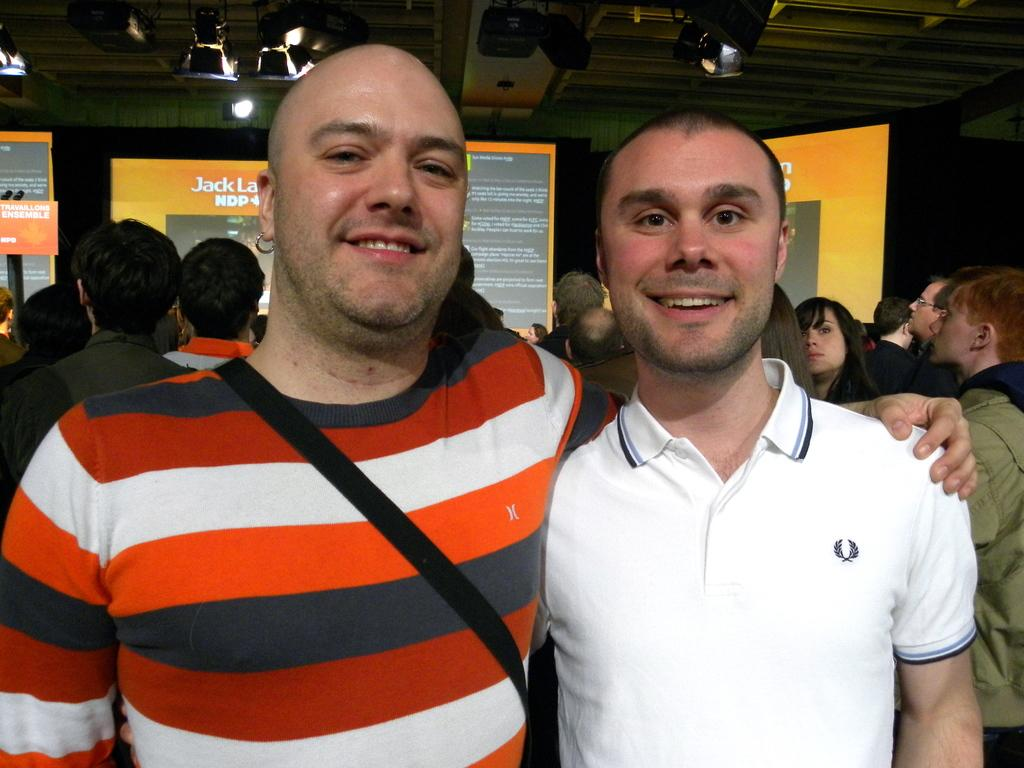<image>
Present a compact description of the photo's key features. A man in a striped shirt with the letter "H" on the front has his arm around another man. 